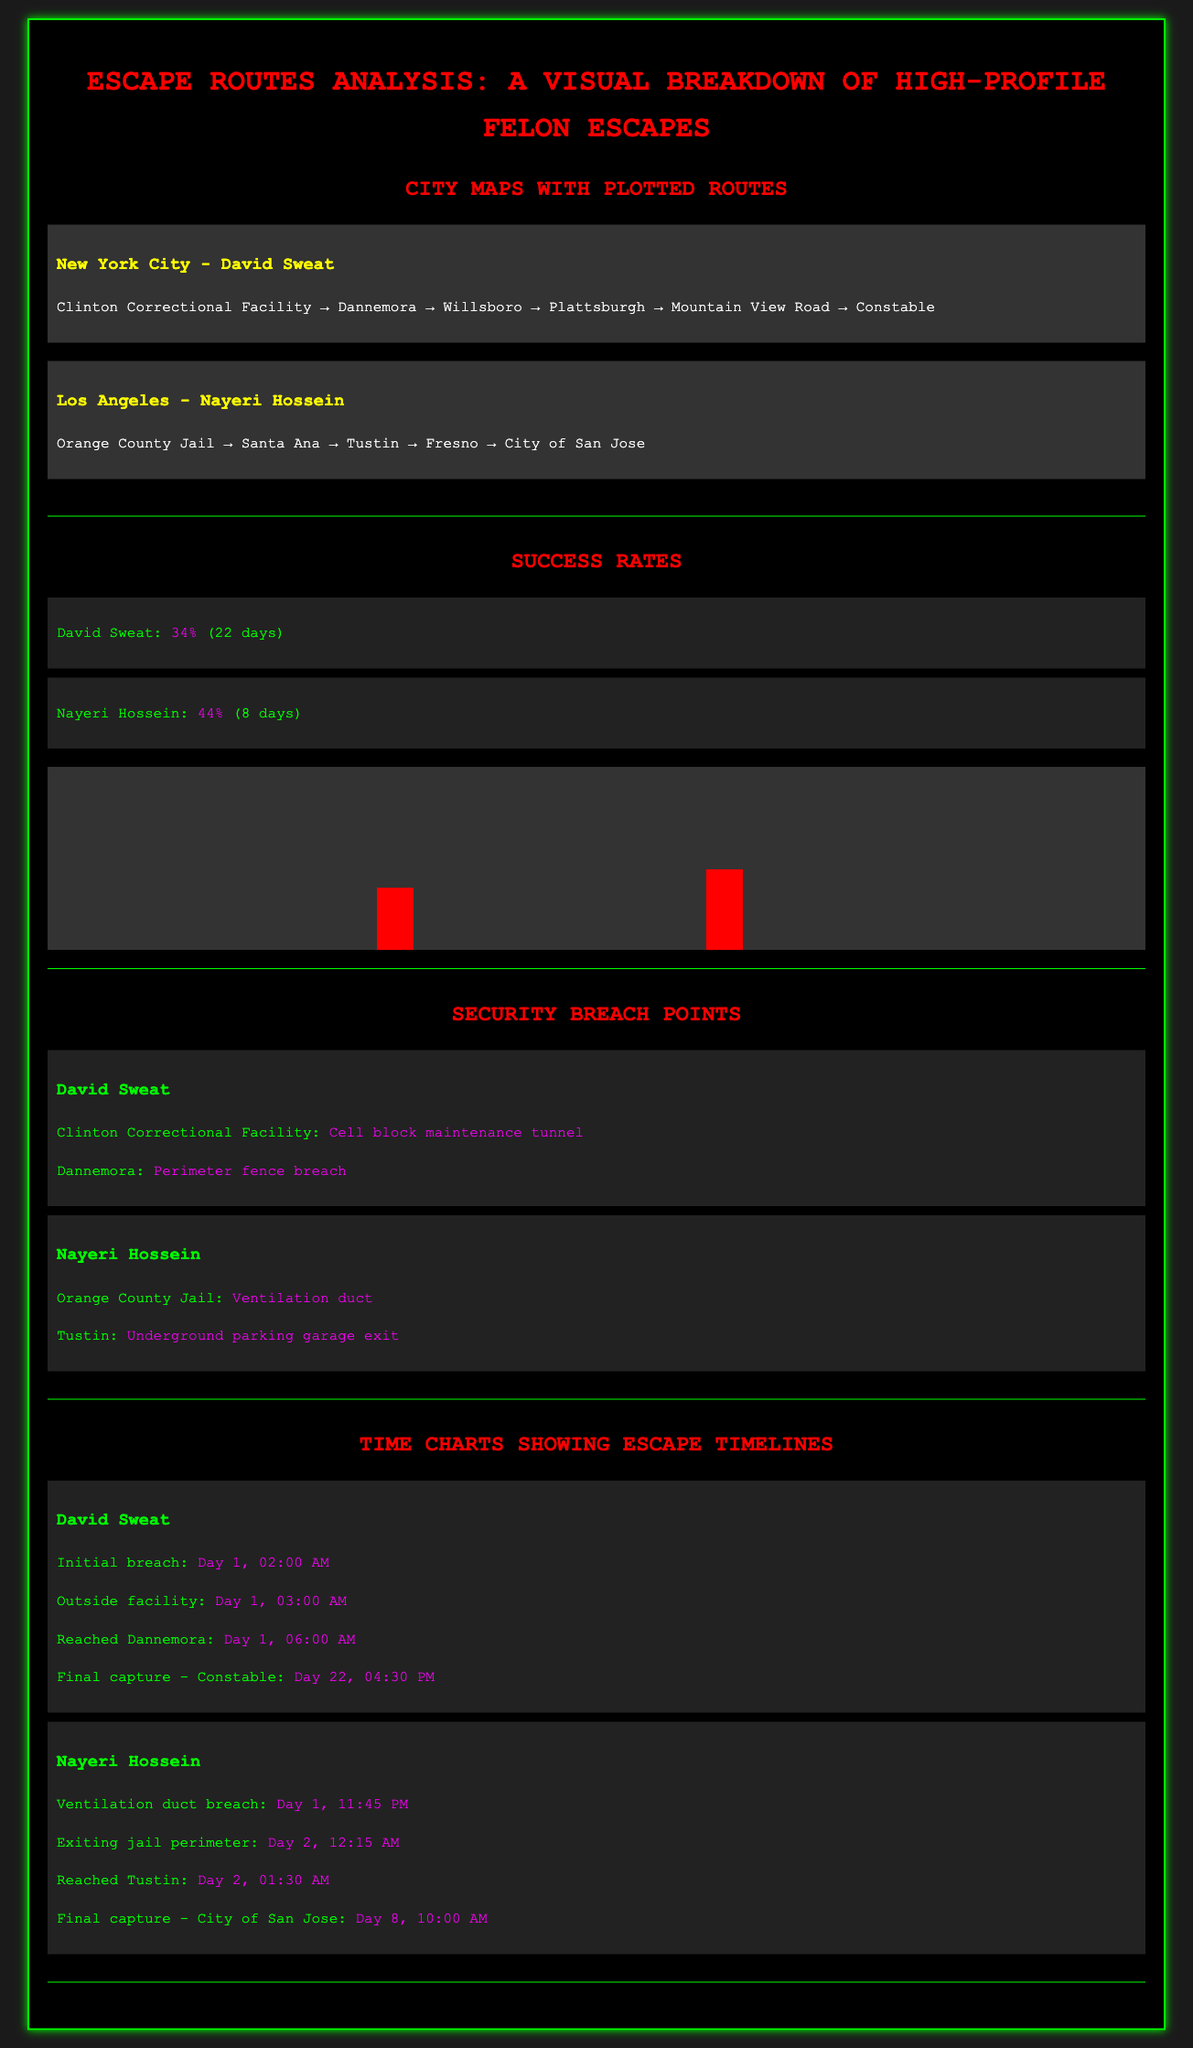What is the escape success rate of David Sweat? The escape success rate is listed as 34% in the success rates section of the document.
Answer: 34% What was the initial breach time for Nayeri Hossein? The initial breach time for Nayeri Hossein is stated as Day 1, 11:45 PM in the timeline section.
Answer: Day 1, 11:45 PM How long did David Sweat's escape take? David Sweat's escape lasted for 22 days according to the success rates section.
Answer: 22 days What security breach point is associated with the Orange County Jail? The breach point for the Orange County Jail is identified as a ventilation duct in the security breach points section.
Answer: Ventilation duct Which city did David Sweat reach after Dannemora? David Sweat reached Willsboro after Dannemora as per the plotted routes in the city maps.
Answer: Willsboro What was the final capture location for Nayeri Hossein? The final capture location for Nayeri Hossein is listed as the City of San Jose in the timeline section.
Answer: City of San Jose What is the success rate of Nayeri Hossein's escape? The success rate for Nayeri Hossein is documented as 44% in the success rates section.
Answer: 44% How many escape points are listed for David Sweat? Two escape points are listed for David Sweat in the security breach points section.
Answer: Two How many days did Nayeri Hossein's escape last? Nayeri Hossein's escape lasted for 8 days as per the success rates section.
Answer: 8 days 